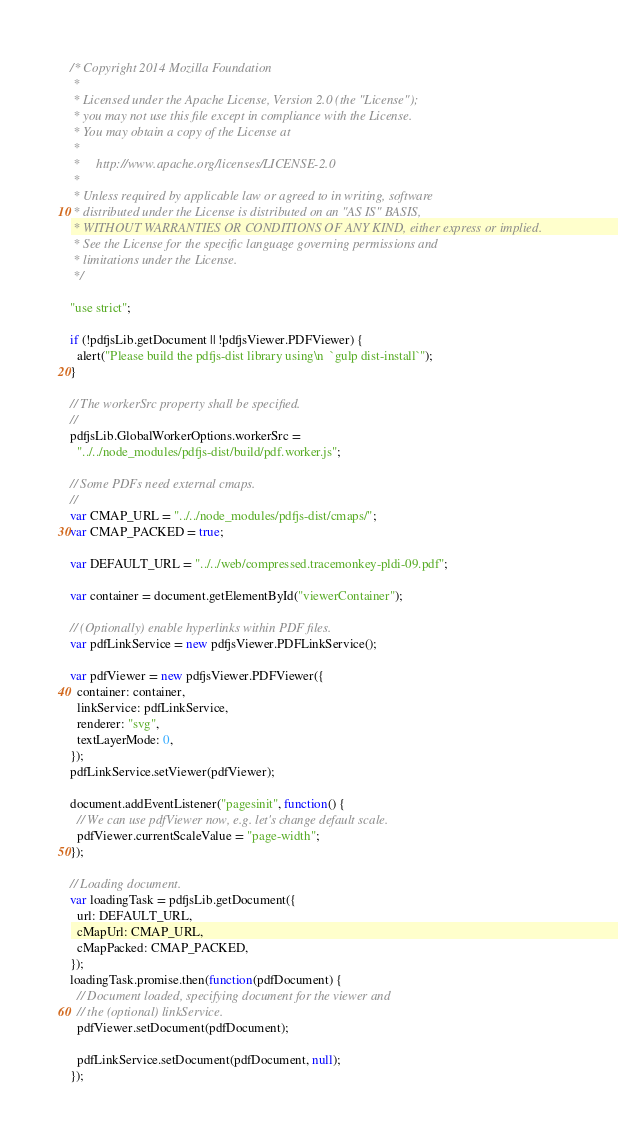Convert code to text. <code><loc_0><loc_0><loc_500><loc_500><_JavaScript_>/* Copyright 2014 Mozilla Foundation
 *
 * Licensed under the Apache License, Version 2.0 (the "License");
 * you may not use this file except in compliance with the License.
 * You may obtain a copy of the License at
 *
 *     http://www.apache.org/licenses/LICENSE-2.0
 *
 * Unless required by applicable law or agreed to in writing, software
 * distributed under the License is distributed on an "AS IS" BASIS,
 * WITHOUT WARRANTIES OR CONDITIONS OF ANY KIND, either express or implied.
 * See the License for the specific language governing permissions and
 * limitations under the License.
 */

"use strict";

if (!pdfjsLib.getDocument || !pdfjsViewer.PDFViewer) {
  alert("Please build the pdfjs-dist library using\n  `gulp dist-install`");
}

// The workerSrc property shall be specified.
//
pdfjsLib.GlobalWorkerOptions.workerSrc =
  "../../node_modules/pdfjs-dist/build/pdf.worker.js";

// Some PDFs need external cmaps.
//
var CMAP_URL = "../../node_modules/pdfjs-dist/cmaps/";
var CMAP_PACKED = true;

var DEFAULT_URL = "../../web/compressed.tracemonkey-pldi-09.pdf";

var container = document.getElementById("viewerContainer");

// (Optionally) enable hyperlinks within PDF files.
var pdfLinkService = new pdfjsViewer.PDFLinkService();

var pdfViewer = new pdfjsViewer.PDFViewer({
  container: container,
  linkService: pdfLinkService,
  renderer: "svg",
  textLayerMode: 0,
});
pdfLinkService.setViewer(pdfViewer);

document.addEventListener("pagesinit", function() {
  // We can use pdfViewer now, e.g. let's change default scale.
  pdfViewer.currentScaleValue = "page-width";
});

// Loading document.
var loadingTask = pdfjsLib.getDocument({
  url: DEFAULT_URL,
  cMapUrl: CMAP_URL,
  cMapPacked: CMAP_PACKED,
});
loadingTask.promise.then(function(pdfDocument) {
  // Document loaded, specifying document for the viewer and
  // the (optional) linkService.
  pdfViewer.setDocument(pdfDocument);

  pdfLinkService.setDocument(pdfDocument, null);
});
</code> 